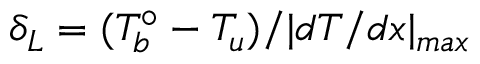Convert formula to latex. <formula><loc_0><loc_0><loc_500><loc_500>\delta _ { L } = ( T _ { b } ^ { \circ } - T _ { u } ) / | d T / d x | _ { \max }</formula> 